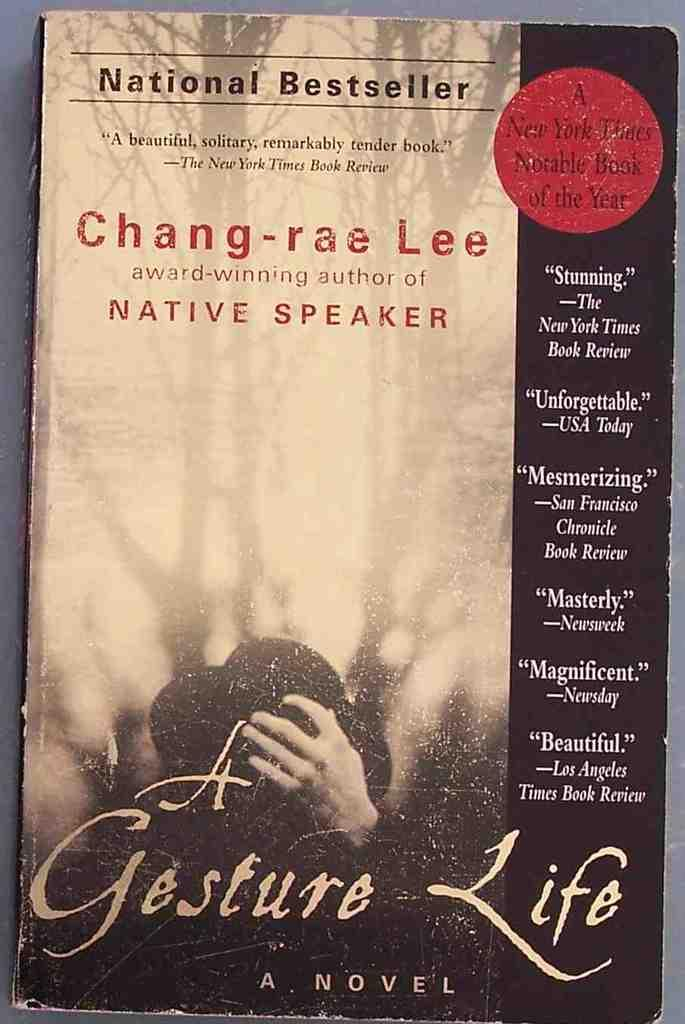<image>
Describe the image concisely. A book called A Gesture Life written by Chang-rae Lee. 